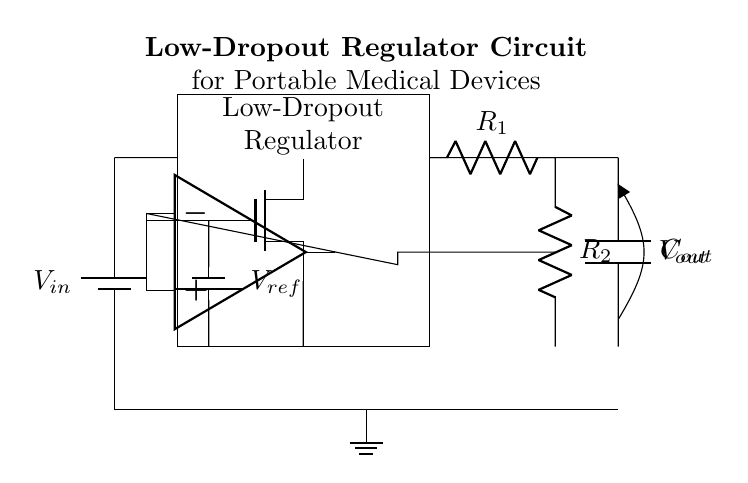What is the input voltage of this circuit? The input voltage is represented by \( V_{in} \) shown connected to the battery symbol at the top left of the circuit diagram.
Answer: \( V_{in} \) What type of regulator is depicted in the circuit? The circuit diagram depicts a Low-Dropout Regulator, which is indicated by the label inside the rectangular block where the nmop and error amplifier are included.
Answer: Low-Dropout Regulator What are the names of the resistors in the feedback network? The resistors are labeled as \( R_1 \) and \( R_2 \) directly shown in the circuit diagram, connected in series to form a voltage divider.
Answer: \( R_1, R_2 \) What component regulates the output voltage in this circuit? The output voltage regulation is primarily managed by the error amplifier, which compares the output voltage against the reference voltage. This is deduced from its connection to the feedback network and the ground.
Answer: Error Amplifier How does the reference voltage \( V_{ref} \) influence the output? The reference voltage \( V_{ref} \) sets a target voltage level for the output by being connected to the error amplifier's positive terminal, which helps maintain the desired output voltage through feedback control.
Answer: Controls Output Voltage What is the purpose of the capacitor \( C_{out} \) in this circuit? The capacitor \( C_{out} \) is primarily used for output smoothing and stability, which helps to minimize voltage fluctuations and provide a stable output for connected loads in portable medical devices.
Answer: Output Smoothing What is the function of the pass transistor in the circuit? The pass transistor in the low-dropout regulator is used to control the flow of current from the input to the output while maintaining a low voltage drop, allowing for higher efficiency, especially important in battery-operated devices.
Answer: Control Current Flow 